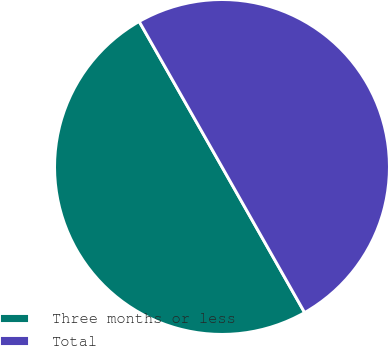Convert chart. <chart><loc_0><loc_0><loc_500><loc_500><pie_chart><fcel>Three months or less<fcel>Total<nl><fcel>49.98%<fcel>50.02%<nl></chart> 